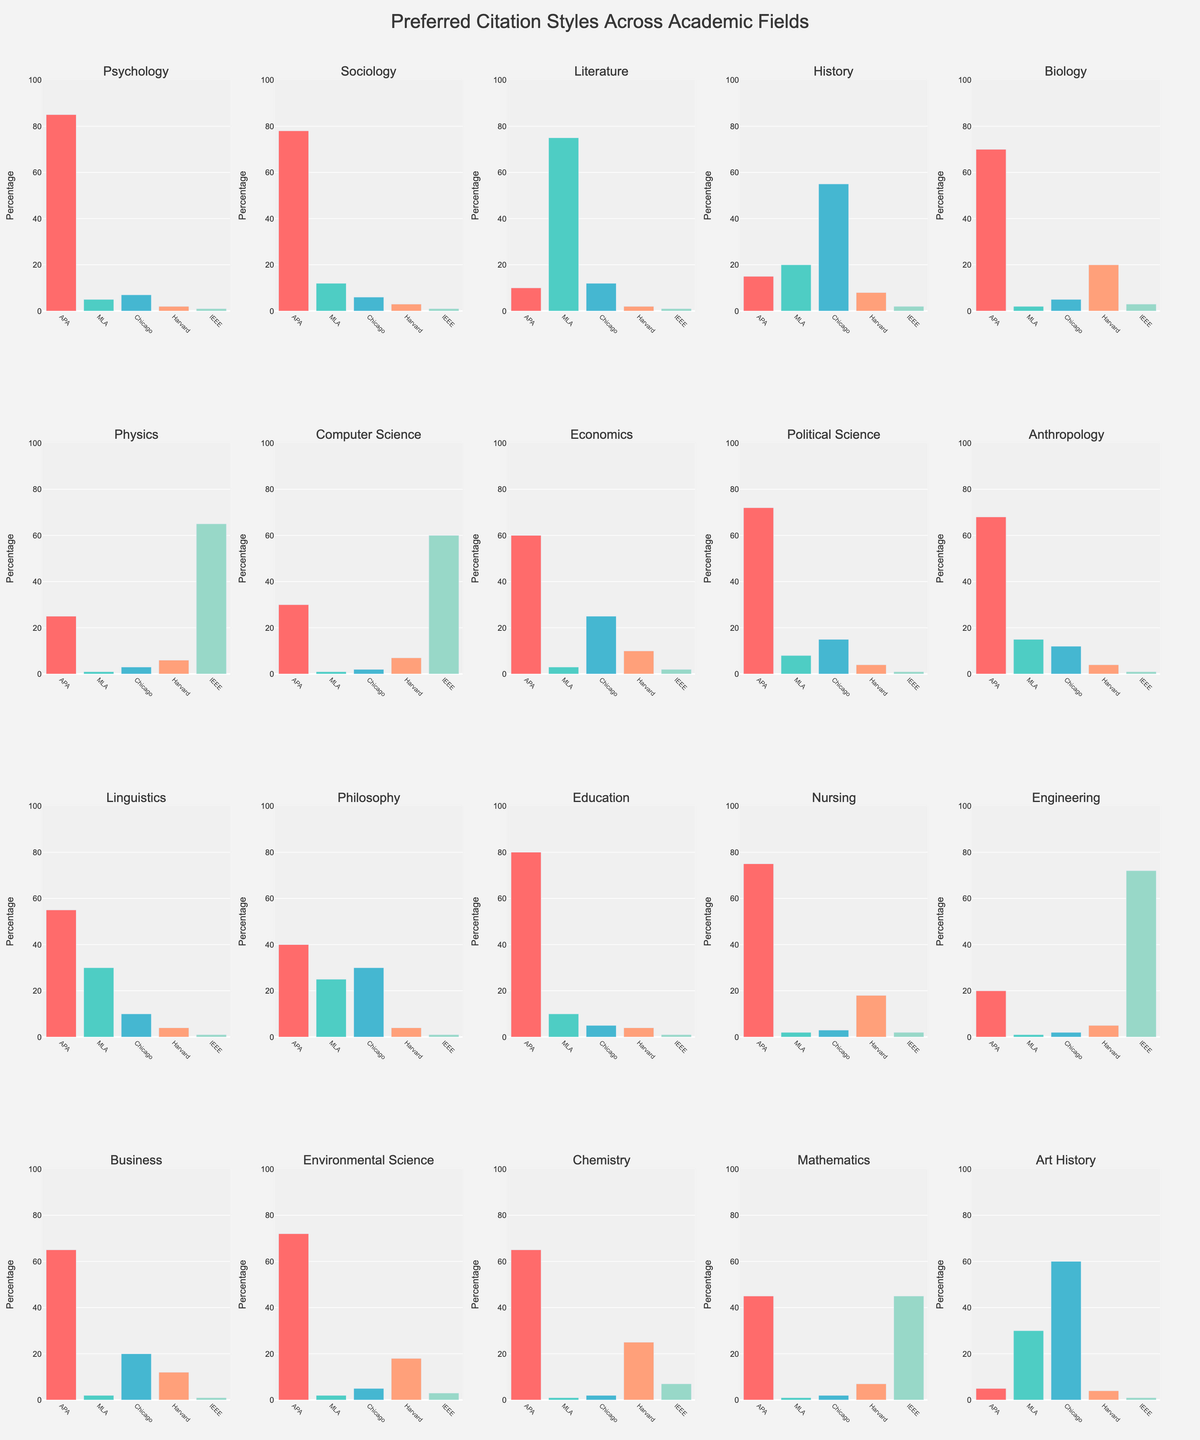Which academic field has the highest preference for APA citation style? By looking at the bars representing the APA citation style, we can see that Psychology has the highest bar, indicating the highest preference for APA citation style.
Answer: Psychology Which citation style is least preferred in the field of Literature? By examining the bars for Literature, the shortest bar corresponds to IEEE style, indicating it is the least preferred.
Answer: IEEE What's the combined percentage of the Chicago and Harvard citation styles in the field of Biology? For Biology, the percentage of Chicago is 5, and Harvard is 20. Summing these percentages gives 5 + 20 = 25.
Answer: 25 Is APA citation style preferred over MLA in the field of Nursing? Comparing the height of the bars for APA and MLA in Nursing, APA (75) is taller than MLA (2).
Answer: Yes Which fields have the highest preference for IEEE citation style? Looking at the bars for IEEE citation style, Physics (65), Computer Science (60), and Engineering (72) have the highest bars.
Answer: Physics, Computer Science, Engineering How many fields have APA as the most preferred citation style? By observing which citation style has the tallest bar in each field, APA is the most preferred in Psychology, Sociology, Biology, Political Science, Anthropology, Education, Nursing, Economics, Business, Environmental Science, and Chemistry, making a total of 11 fields.
Answer: 11 What is the difference in preference between APA and Chicago citation styles in Economics? In Economics, APA is 60 and Chicago is 25. The difference is 60 - 25 = 35.
Answer: 35 Is the preference for the Harvard citation style in the field of Art History greater than in the field of Chemistry? By comparing the heights of the bars for Harvard in both fields, Art History has a Harvard preference of 4, while Chemistry has 25.
Answer: No What percentage of the MLA citation style is preferred in the field of Linguistics? Looking at the bar for MLA in Linguistics, it shows a preference of 30.
Answer: 30 Which citation style is most preferred in the field of History? For History, the tallest bar is for Chicago citation style.
Answer: Chicago 